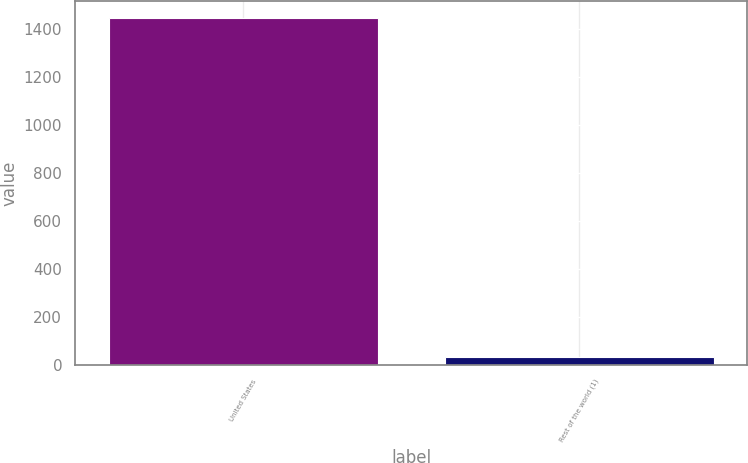<chart> <loc_0><loc_0><loc_500><loc_500><bar_chart><fcel>United States<fcel>Rest of the world (1)<nl><fcel>1444<fcel>31<nl></chart> 